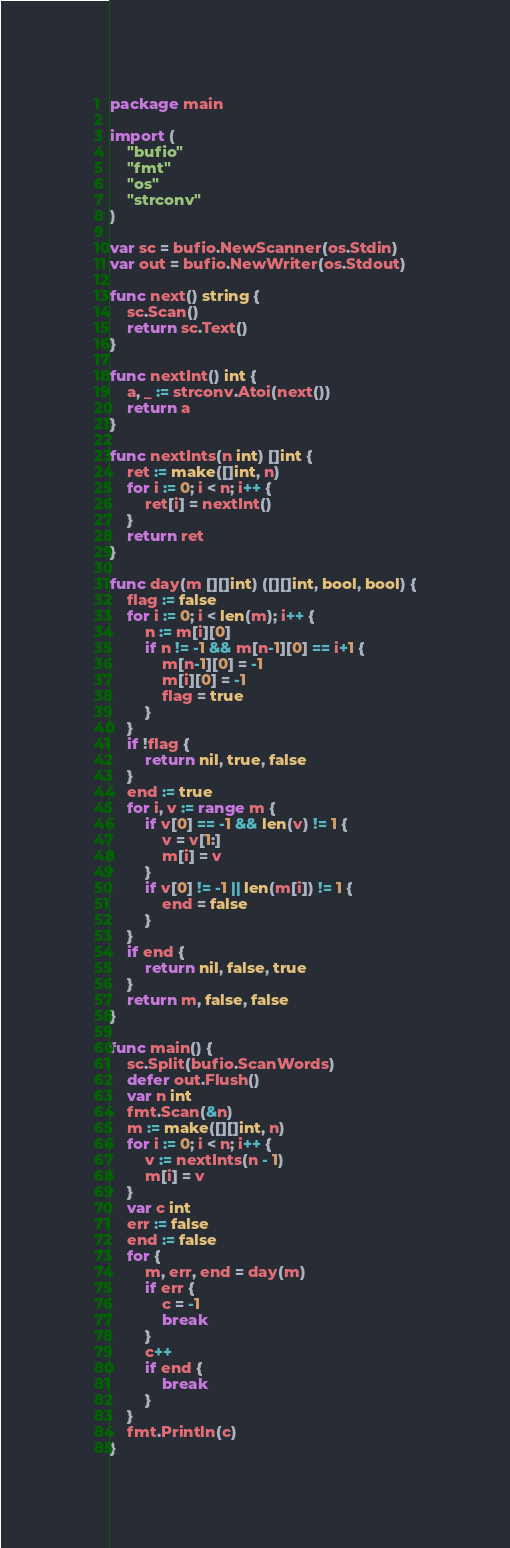Convert code to text. <code><loc_0><loc_0><loc_500><loc_500><_Go_>package main

import (
	"bufio"
	"fmt"
	"os"
	"strconv"
)

var sc = bufio.NewScanner(os.Stdin)
var out = bufio.NewWriter(os.Stdout)

func next() string {
	sc.Scan()
	return sc.Text()
}

func nextInt() int {
	a, _ := strconv.Atoi(next())
	return a
}

func nextInts(n int) []int {
	ret := make([]int, n)
	for i := 0; i < n; i++ {
		ret[i] = nextInt()
	}
	return ret
}

func day(m [][]int) ([][]int, bool, bool) {
	flag := false
	for i := 0; i < len(m); i++ {
		n := m[i][0]
		if n != -1 && m[n-1][0] == i+1 {
			m[n-1][0] = -1
			m[i][0] = -1
			flag = true
		}
	}
	if !flag {
		return nil, true, false
	}
	end := true
	for i, v := range m {
		if v[0] == -1 && len(v) != 1 {
			v = v[1:]
			m[i] = v
		}
		if v[0] != -1 || len(m[i]) != 1 {
			end = false
		}
	}
	if end {
		return nil, false, true
	}
	return m, false, false
}

func main() {
	sc.Split(bufio.ScanWords)
	defer out.Flush()
	var n int
	fmt.Scan(&n)
	m := make([][]int, n)
	for i := 0; i < n; i++ {
		v := nextInts(n - 1)
		m[i] = v
	}
	var c int
	err := false
	end := false
	for {
		m, err, end = day(m)
		if err {
			c = -1
			break
		}
		c++
		if end {
			break
		}
	}
	fmt.Println(c)
}
</code> 